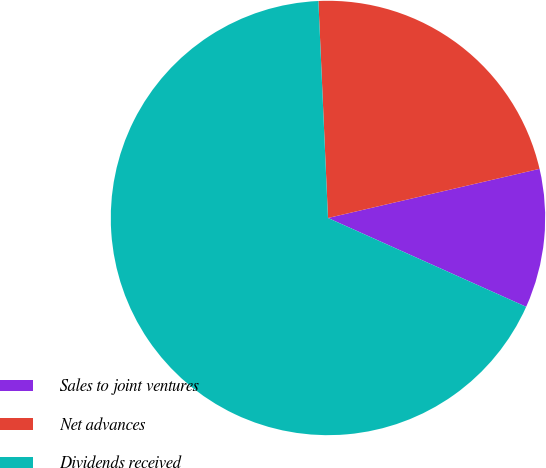Convert chart to OTSL. <chart><loc_0><loc_0><loc_500><loc_500><pie_chart><fcel>Sales to joint ventures<fcel>Net advances<fcel>Dividends received<nl><fcel>10.34%<fcel>22.07%<fcel>67.59%<nl></chart> 